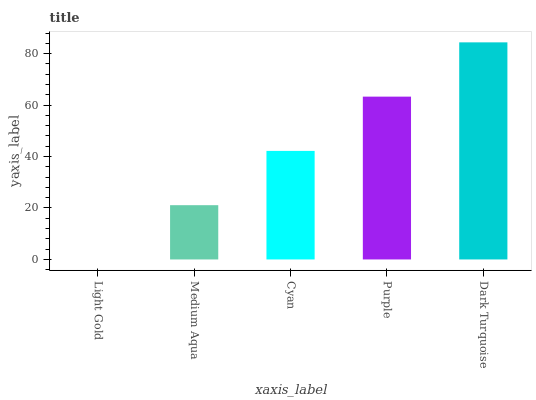Is Light Gold the minimum?
Answer yes or no. Yes. Is Dark Turquoise the maximum?
Answer yes or no. Yes. Is Medium Aqua the minimum?
Answer yes or no. No. Is Medium Aqua the maximum?
Answer yes or no. No. Is Medium Aqua greater than Light Gold?
Answer yes or no. Yes. Is Light Gold less than Medium Aqua?
Answer yes or no. Yes. Is Light Gold greater than Medium Aqua?
Answer yes or no. No. Is Medium Aqua less than Light Gold?
Answer yes or no. No. Is Cyan the high median?
Answer yes or no. Yes. Is Cyan the low median?
Answer yes or no. Yes. Is Light Gold the high median?
Answer yes or no. No. Is Light Gold the low median?
Answer yes or no. No. 